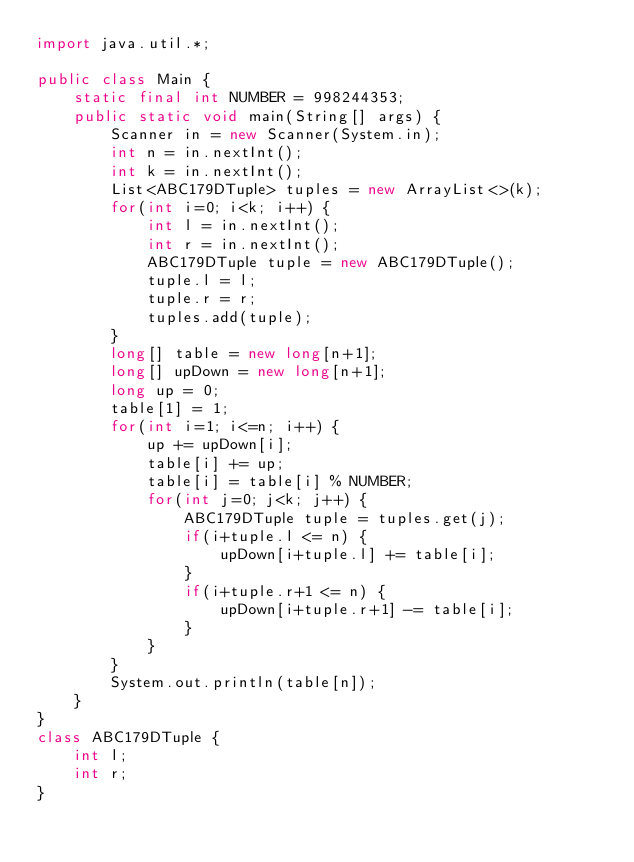Convert code to text. <code><loc_0><loc_0><loc_500><loc_500><_Java_>import java.util.*;

public class Main {
    static final int NUMBER = 998244353;
    public static void main(String[] args) {
        Scanner in = new Scanner(System.in);
        int n = in.nextInt();
        int k = in.nextInt();
        List<ABC179DTuple> tuples = new ArrayList<>(k);
        for(int i=0; i<k; i++) {
            int l = in.nextInt();
            int r = in.nextInt();
            ABC179DTuple tuple = new ABC179DTuple();
            tuple.l = l;
            tuple.r = r;
            tuples.add(tuple);
        }
        long[] table = new long[n+1];
        long[] upDown = new long[n+1];
        long up = 0;
        table[1] = 1;
        for(int i=1; i<=n; i++) {
            up += upDown[i];
            table[i] += up;
            table[i] = table[i] % NUMBER;
            for(int j=0; j<k; j++) {
                ABC179DTuple tuple = tuples.get(j);
                if(i+tuple.l <= n) {
                    upDown[i+tuple.l] += table[i];
                }
                if(i+tuple.r+1 <= n) {
                    upDown[i+tuple.r+1] -= table[i];
                }
            }
        }
        System.out.println(table[n]);
    }
}
class ABC179DTuple {
    int l;
    int r;
}
</code> 